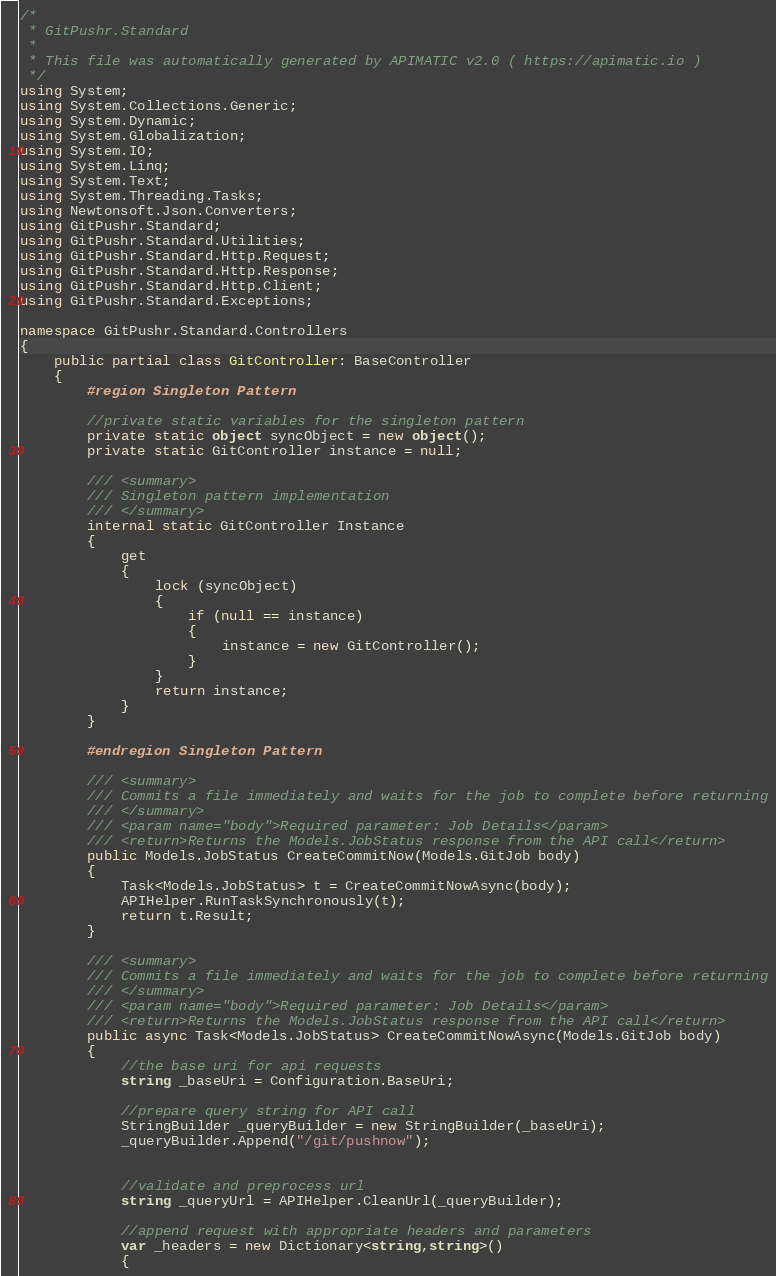Convert code to text. <code><loc_0><loc_0><loc_500><loc_500><_C#_>/*
 * GitPushr.Standard
 *
 * This file was automatically generated by APIMATIC v2.0 ( https://apimatic.io )
 */
using System;
using System.Collections.Generic;
using System.Dynamic;
using System.Globalization;
using System.IO;
using System.Linq;
using System.Text;
using System.Threading.Tasks;
using Newtonsoft.Json.Converters;
using GitPushr.Standard;
using GitPushr.Standard.Utilities;
using GitPushr.Standard.Http.Request;
using GitPushr.Standard.Http.Response;
using GitPushr.Standard.Http.Client;
using GitPushr.Standard.Exceptions;

namespace GitPushr.Standard.Controllers
{
    public partial class GitController: BaseController
    {
        #region Singleton Pattern

        //private static variables for the singleton pattern
        private static object syncObject = new object();
        private static GitController instance = null;

        /// <summary>
        /// Singleton pattern implementation
        /// </summary>
        internal static GitController Instance
        {
            get
            {
                lock (syncObject)
                {
                    if (null == instance)
                    {
                        instance = new GitController();
                    }
                }
                return instance;
            }
        }

        #endregion Singleton Pattern

        /// <summary>
        /// Commits a file immediately and waits for the job to complete before returning
        /// </summary>
        /// <param name="body">Required parameter: Job Details</param>
        /// <return>Returns the Models.JobStatus response from the API call</return>
        public Models.JobStatus CreateCommitNow(Models.GitJob body)
        {
            Task<Models.JobStatus> t = CreateCommitNowAsync(body);
            APIHelper.RunTaskSynchronously(t);
            return t.Result;
        }

        /// <summary>
        /// Commits a file immediately and waits for the job to complete before returning
        /// </summary>
        /// <param name="body">Required parameter: Job Details</param>
        /// <return>Returns the Models.JobStatus response from the API call</return>
        public async Task<Models.JobStatus> CreateCommitNowAsync(Models.GitJob body)
        {
            //the base uri for api requests
            string _baseUri = Configuration.BaseUri;

            //prepare query string for API call
            StringBuilder _queryBuilder = new StringBuilder(_baseUri);
            _queryBuilder.Append("/git/pushnow");


            //validate and preprocess url
            string _queryUrl = APIHelper.CleanUrl(_queryBuilder);

            //append request with appropriate headers and parameters
            var _headers = new Dictionary<string,string>()
            {</code> 